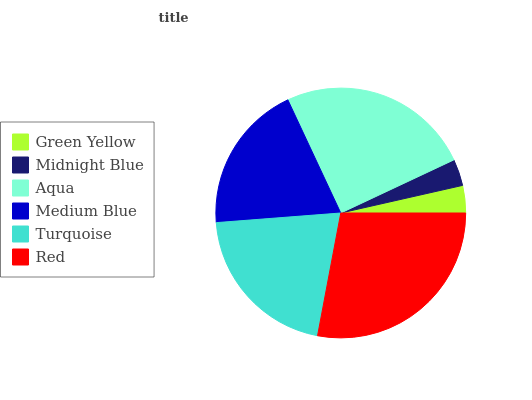Is Midnight Blue the minimum?
Answer yes or no. Yes. Is Red the maximum?
Answer yes or no. Yes. Is Aqua the minimum?
Answer yes or no. No. Is Aqua the maximum?
Answer yes or no. No. Is Aqua greater than Midnight Blue?
Answer yes or no. Yes. Is Midnight Blue less than Aqua?
Answer yes or no. Yes. Is Midnight Blue greater than Aqua?
Answer yes or no. No. Is Aqua less than Midnight Blue?
Answer yes or no. No. Is Turquoise the high median?
Answer yes or no. Yes. Is Medium Blue the low median?
Answer yes or no. Yes. Is Midnight Blue the high median?
Answer yes or no. No. Is Green Yellow the low median?
Answer yes or no. No. 